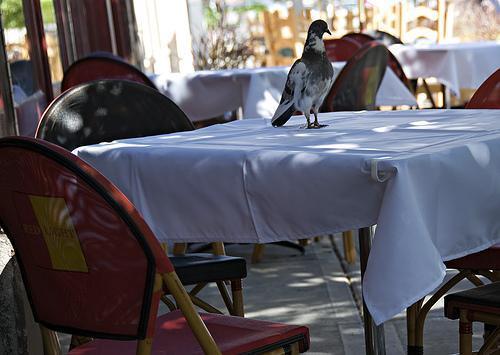How many tables can be seen?
Give a very brief answer. 3. How many chairs are shown?
Give a very brief answer. 7. How many chairs are there?
Give a very brief answer. 6. 